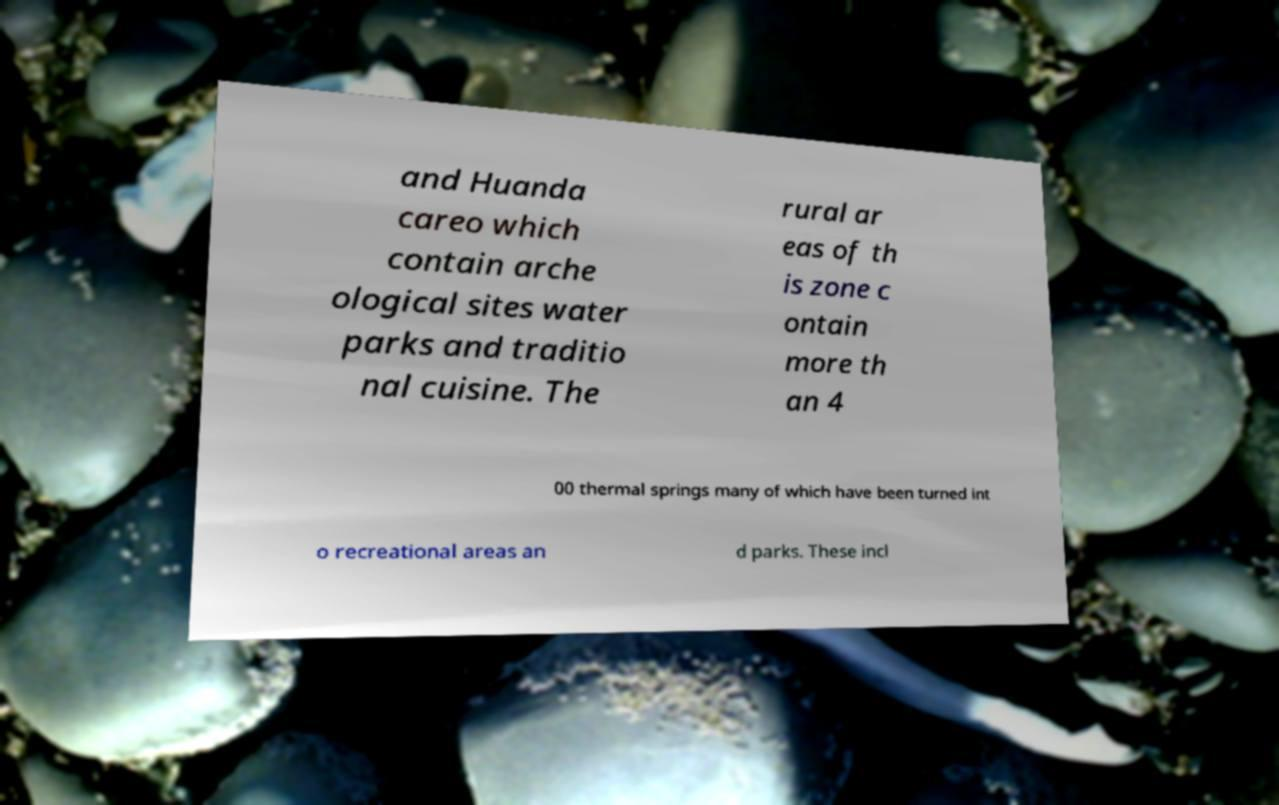Please identify and transcribe the text found in this image. and Huanda careo which contain arche ological sites water parks and traditio nal cuisine. The rural ar eas of th is zone c ontain more th an 4 00 thermal springs many of which have been turned int o recreational areas an d parks. These incl 